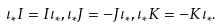<formula> <loc_0><loc_0><loc_500><loc_500>\iota _ { * } I = I \iota _ { * } , \iota _ { * } J = - J \iota _ { * } , \iota _ { * } K = - K \iota _ { * } .</formula> 